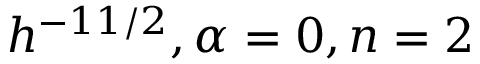<formula> <loc_0><loc_0><loc_500><loc_500>h ^ { - 1 1 / 2 } , \alpha = 0 , n = 2</formula> 